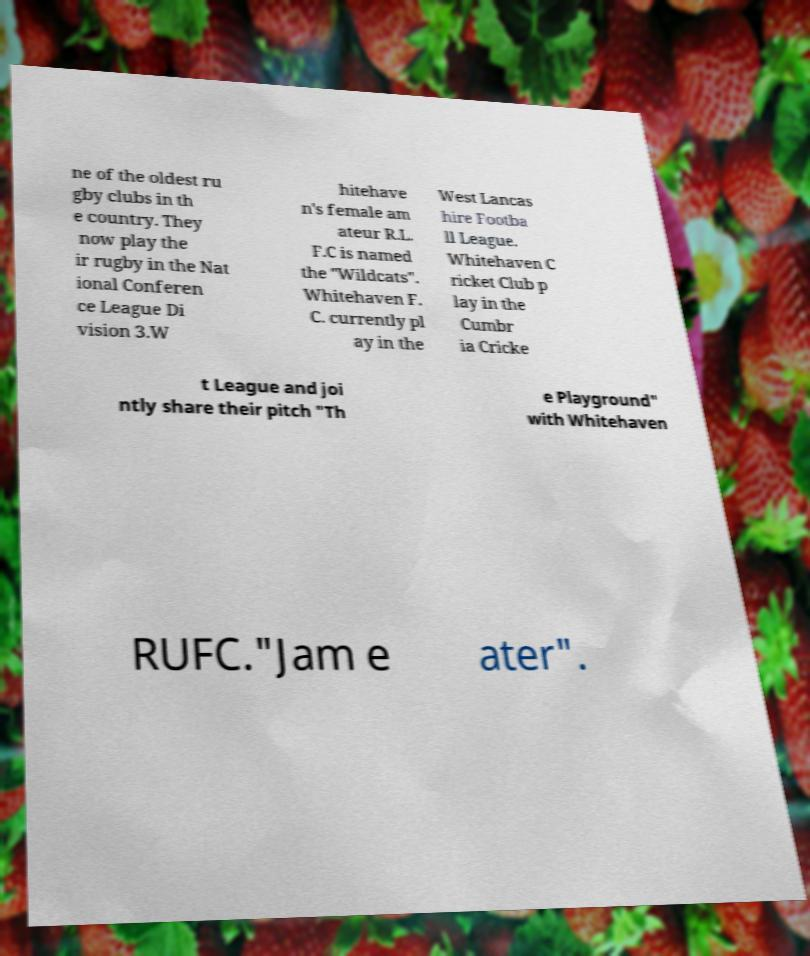Could you assist in decoding the text presented in this image and type it out clearly? ne of the oldest ru gby clubs in th e country. They now play the ir rugby in the Nat ional Conferen ce League Di vision 3.W hitehave n's female am ateur R.L. F.C is named the "Wildcats". Whitehaven F. C. currently pl ay in the West Lancas hire Footba ll League. Whitehaven C ricket Club p lay in the Cumbr ia Cricke t League and joi ntly share their pitch "Th e Playground" with Whitehaven RUFC."Jam e ater". 